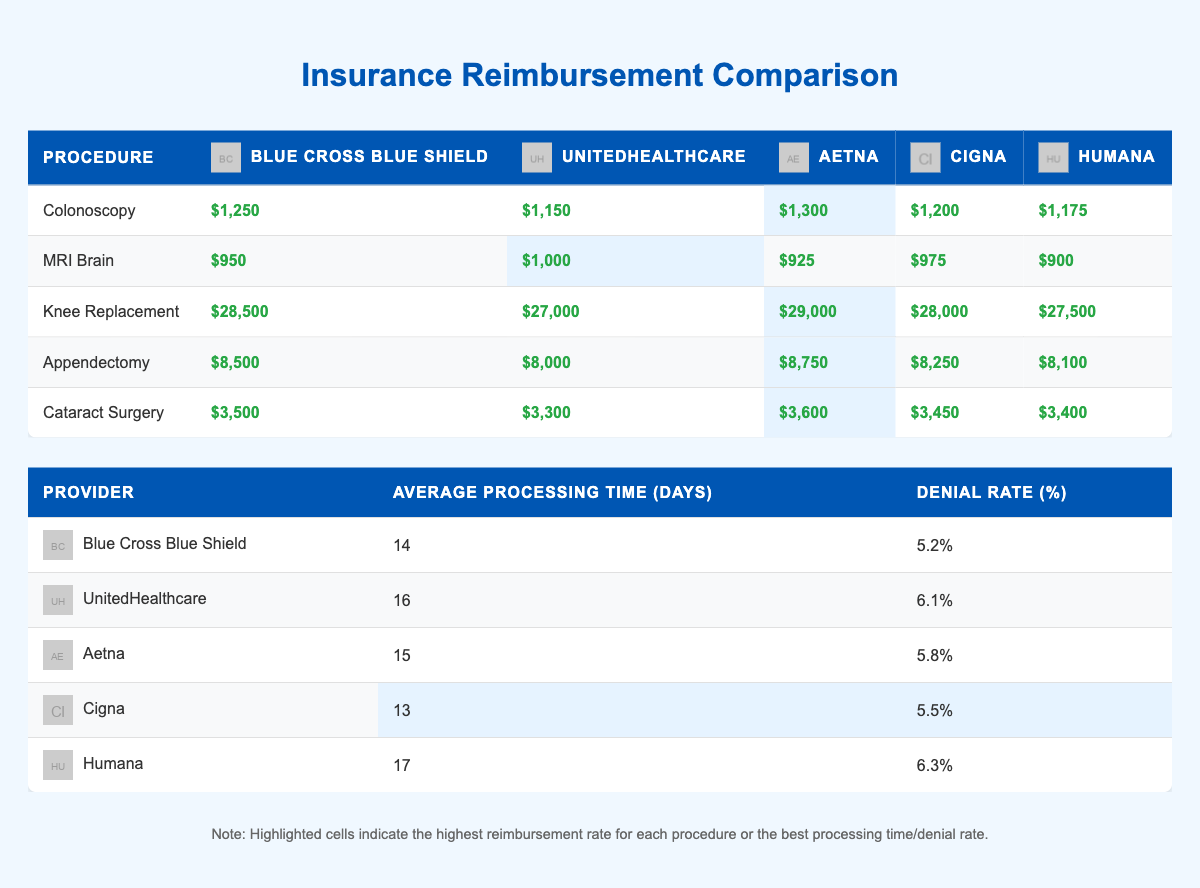What is the reimbursement rate for a Colonoscopy from Aetna? The table lists the reimbursement rates for a Colonoscopy under Aetna as $1,300.
Answer: $1,300 Which insurance provider offers the highest reimbursement for Knee Replacement? Aetna has the highest reimbursement rate for Knee Replacement at $29,000, as highlighted in the table.
Answer: Aetna What is the average processing time for Blue Cross Blue Shield? The table indicates that the average processing time for Blue Cross Blue Shield is 14 days.
Answer: 14 days Which procedure has the lowest reimbursement rate from Humana? According to the table, Humana has the lowest reimbursement rate for an MRI Brain at $900.
Answer: $900 What is the difference in reimbursement rates for an Appendectomy between UnitedHealthcare and Cigna? The reimbursement for an Appendectomy from UnitedHealthcare is $8,000 and from Cigna is $8,250. The difference is $8,250 - $8,000 = $250.
Answer: $250 Is the denial rate for Cigna lower than for UnitedHealthcare? Cigna's denial rate is 5.5% while UnitedHealthcare's is 6.1%, which confirms that Cigna has a lower denial rate.
Answer: Yes What is the average reimbursement rate for Cataract Surgery from all providers? The reimbursement rates for Cataract Surgery from all providers are $3,500, $3,300, $3,600, $3,450, and $3,400. Summing them gives $17,250, and dividing by 5 yields an average of $3,450.
Answer: $3,450 Which insurance provider has the shortest average processing time? Cigna has the shortest average processing time of 13 days, as shown in the table.
Answer: Cigna How does the reimbursement for a Colonoscopy compare to that of an Appendectomy from Blue Cross Blue Shield? Blue Cross Blue Shield reimburses $1,250 for a Colonoscopy and $8,500 for an Appendectomy. Therefore, Appendectomy reimbursement is higher by $8,500 - $1,250 = $7,250.
Answer: $7,250 